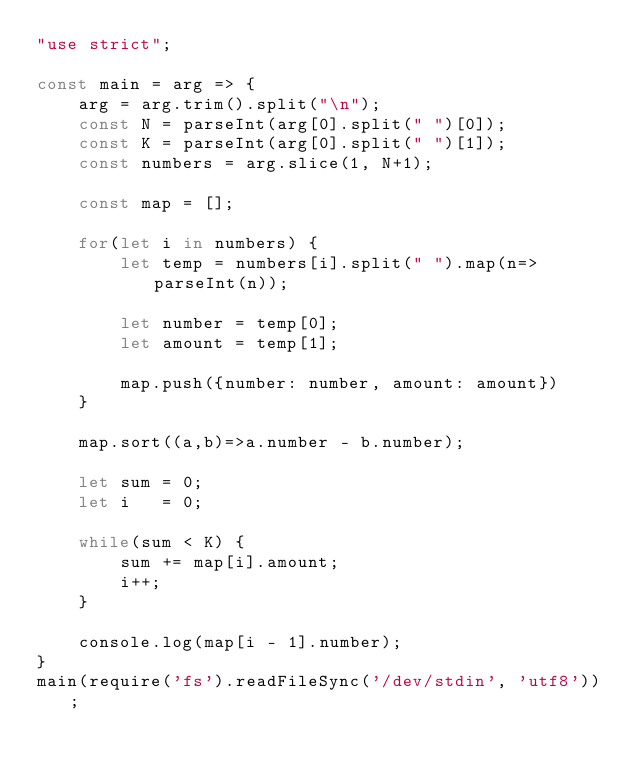<code> <loc_0><loc_0><loc_500><loc_500><_JavaScript_>"use strict";
    
const main = arg => {
    arg = arg.trim().split("\n");
    const N = parseInt(arg[0].split(" ")[0]);
    const K = parseInt(arg[0].split(" ")[1]);
    const numbers = arg.slice(1, N+1);
    
    const map = [];
    
    for(let i in numbers) {
        let temp = numbers[i].split(" ").map(n=>parseInt(n));
        
        let number = temp[0];
        let amount = temp[1];
        
        map.push({number: number, amount: amount})
    }
    
    map.sort((a,b)=>a.number - b.number);
    
    let sum = 0;
    let i   = 0;
    
    while(sum < K) {
        sum += map[i].amount;
        i++;
    }
    
    console.log(map[i - 1].number);
}
main(require('fs').readFileSync('/dev/stdin', 'utf8'));
</code> 